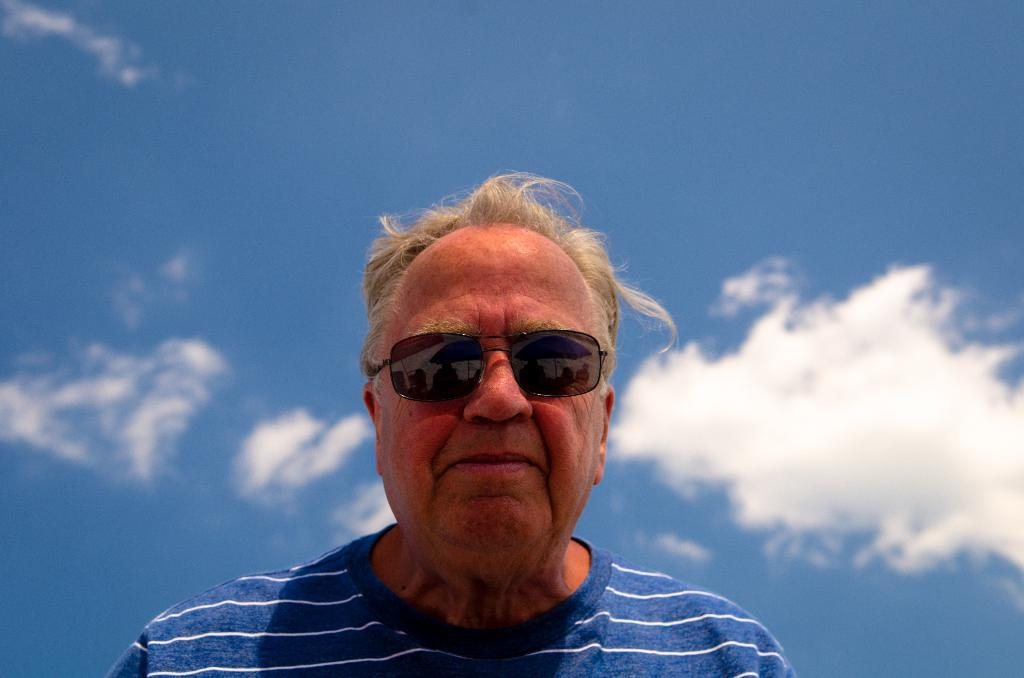What is the main subject in the foreground of the image? There is a man in the foreground of the image. What can be seen in the background of the image? The background of the image includes the blue sky. Based on the presence of the blue sky, can we determine the time of day the image was taken? The image was likely taken during the day, as the blue sky is a common daytime feature. What type of reward is the man holding in the image? There is no reward visible in the image; the man is not holding anything. What is the man doing with his lips in the image? The man's lips are not visible in the image, so it is impossible to determine what he is doing with them. 